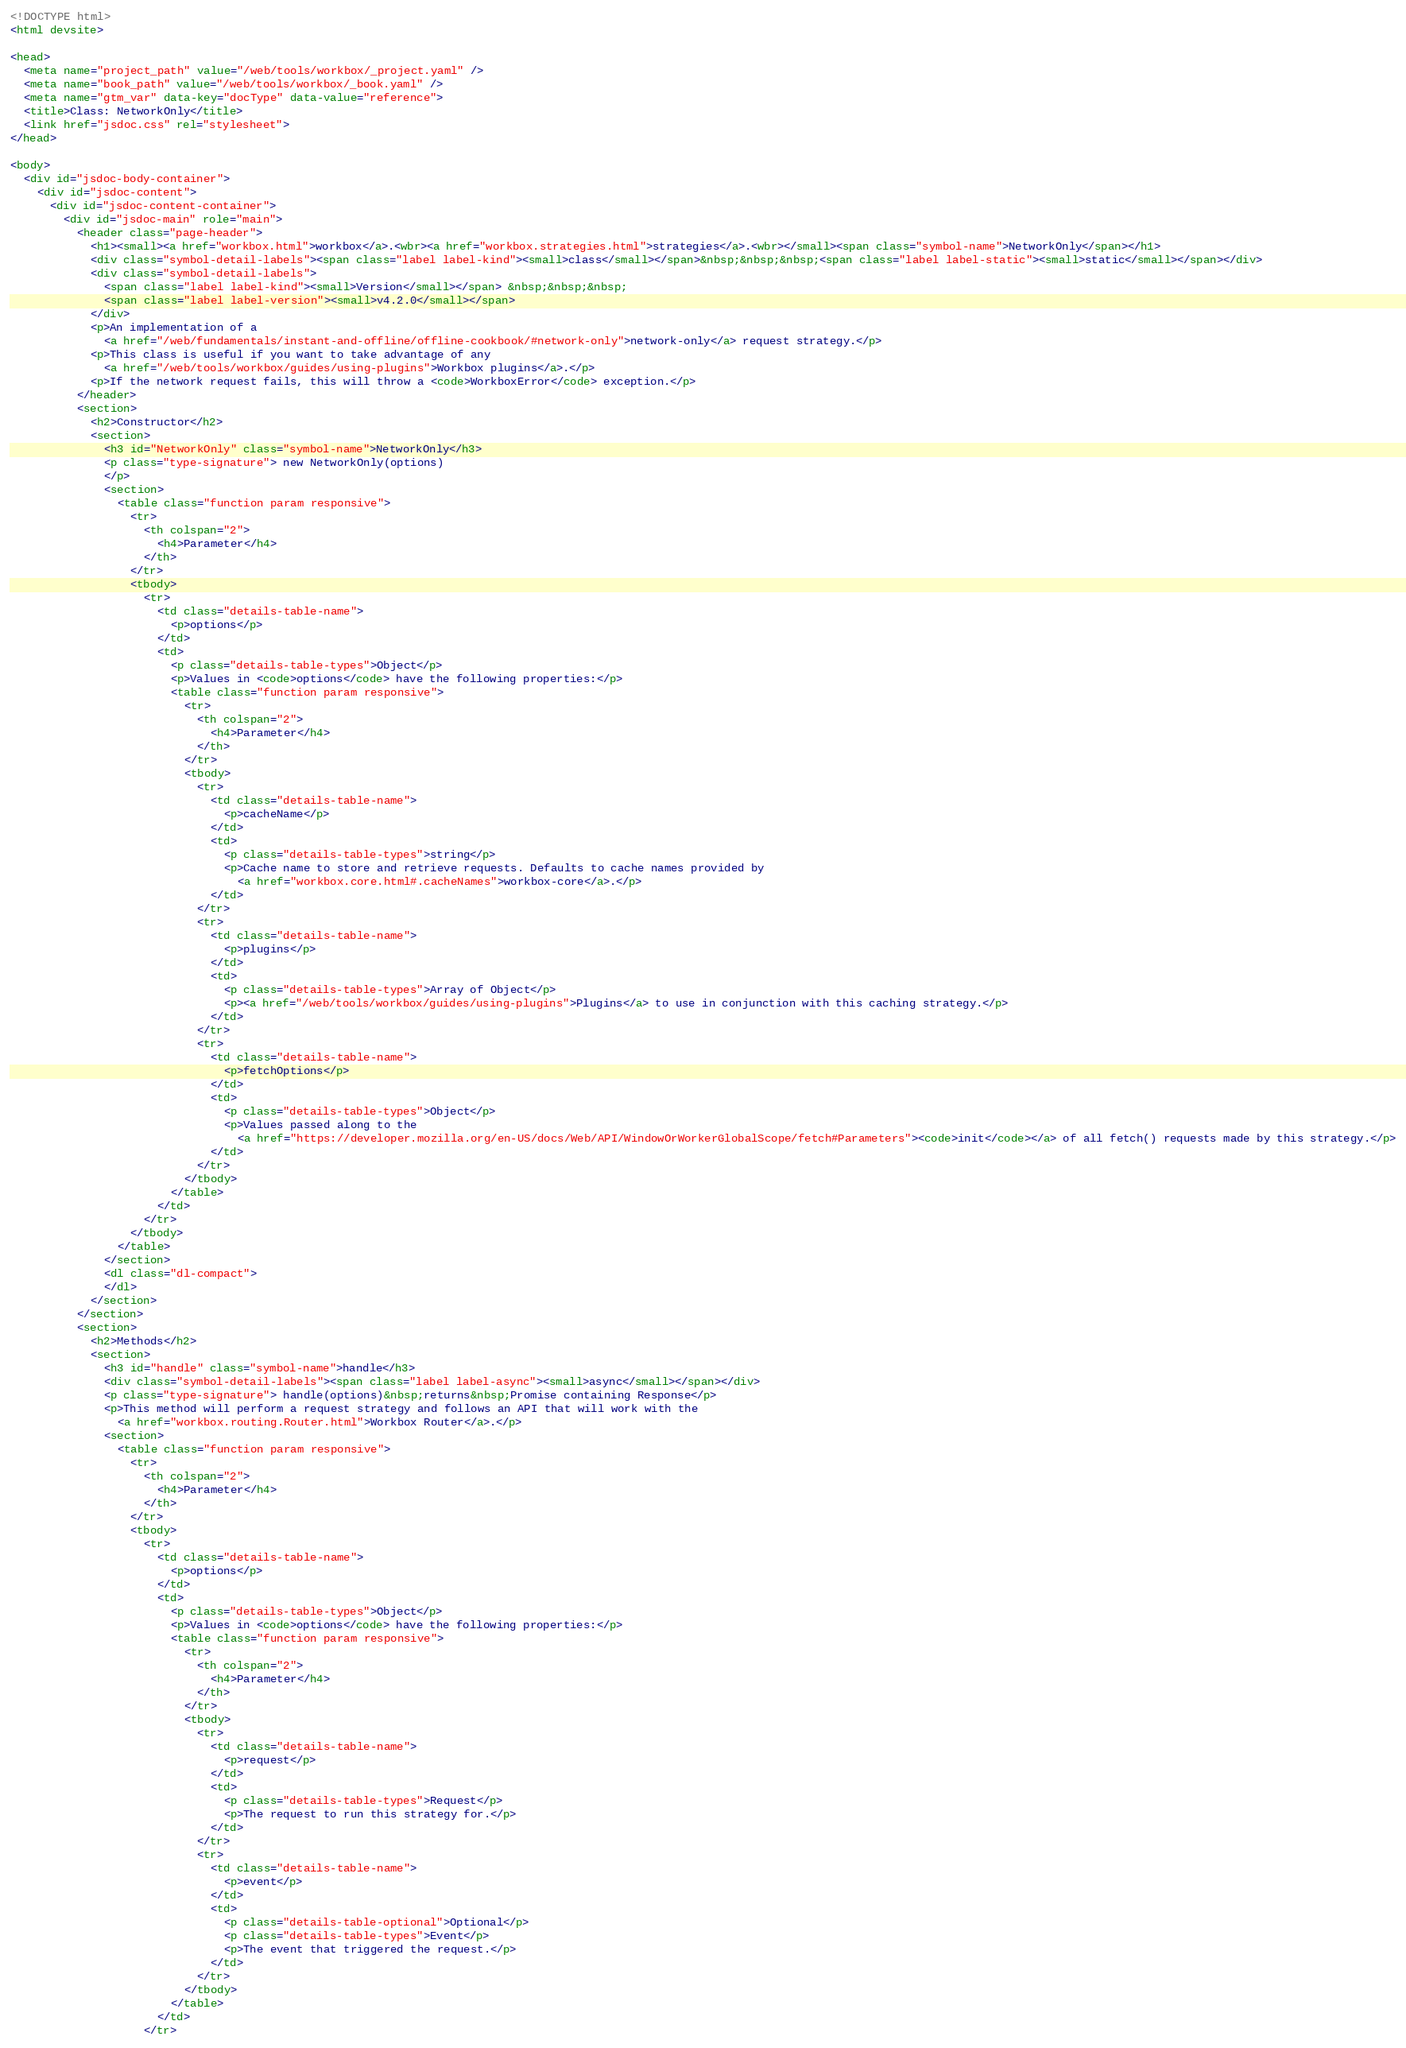Convert code to text. <code><loc_0><loc_0><loc_500><loc_500><_HTML_><!DOCTYPE html>
<html devsite>

<head>
  <meta name="project_path" value="/web/tools/workbox/_project.yaml" />
  <meta name="book_path" value="/web/tools/workbox/_book.yaml" />
  <meta name="gtm_var" data-key="docType" data-value="reference">
  <title>Class: NetworkOnly</title>
  <link href="jsdoc.css" rel="stylesheet">
</head>

<body>
  <div id="jsdoc-body-container">
    <div id="jsdoc-content">
      <div id="jsdoc-content-container">
        <div id="jsdoc-main" role="main">
          <header class="page-header">
            <h1><small><a href="workbox.html">workbox</a>.<wbr><a href="workbox.strategies.html">strategies</a>.<wbr></small><span class="symbol-name">NetworkOnly</span></h1>
            <div class="symbol-detail-labels"><span class="label label-kind"><small>class</small></span>&nbsp;&nbsp;&nbsp;<span class="label label-static"><small>static</small></span></div>
            <div class="symbol-detail-labels">
              <span class="label label-kind"><small>Version</small></span> &nbsp;&nbsp;&nbsp;
              <span class="label label-version"><small>v4.2.0</small></span>
            </div>
            <p>An implementation of a
              <a href="/web/fundamentals/instant-and-offline/offline-cookbook/#network-only">network-only</a> request strategy.</p>
            <p>This class is useful if you want to take advantage of any
              <a href="/web/tools/workbox/guides/using-plugins">Workbox plugins</a>.</p>
            <p>If the network request fails, this will throw a <code>WorkboxError</code> exception.</p>
          </header>
          <section>
            <h2>Constructor</h2>
            <section>
              <h3 id="NetworkOnly" class="symbol-name">NetworkOnly</h3>
              <p class="type-signature"> new NetworkOnly(options)
              </p>
              <section>
                <table class="function param responsive">
                  <tr>
                    <th colspan="2">
                      <h4>Parameter</h4>
                    </th>
                  </tr>
                  <tbody>
                    <tr>
                      <td class="details-table-name">
                        <p>options</p>
                      </td>
                      <td>
                        <p class="details-table-types">Object</p>
                        <p>Values in <code>options</code> have the following properties:</p>
                        <table class="function param responsive">
                          <tr>
                            <th colspan="2">
                              <h4>Parameter</h4>
                            </th>
                          </tr>
                          <tbody>
                            <tr>
                              <td class="details-table-name">
                                <p>cacheName</p>
                              </td>
                              <td>
                                <p class="details-table-types">string</p>
                                <p>Cache name to store and retrieve requests. Defaults to cache names provided by
                                  <a href="workbox.core.html#.cacheNames">workbox-core</a>.</p>
                              </td>
                            </tr>
                            <tr>
                              <td class="details-table-name">
                                <p>plugins</p>
                              </td>
                              <td>
                                <p class="details-table-types">Array of Object</p>
                                <p><a href="/web/tools/workbox/guides/using-plugins">Plugins</a> to use in conjunction with this caching strategy.</p>
                              </td>
                            </tr>
                            <tr>
                              <td class="details-table-name">
                                <p>fetchOptions</p>
                              </td>
                              <td>
                                <p class="details-table-types">Object</p>
                                <p>Values passed along to the
                                  <a href="https://developer.mozilla.org/en-US/docs/Web/API/WindowOrWorkerGlobalScope/fetch#Parameters"><code>init</code></a> of all fetch() requests made by this strategy.</p>
                              </td>
                            </tr>
                          </tbody>
                        </table>
                      </td>
                    </tr>
                  </tbody>
                </table>
              </section>
              <dl class="dl-compact">
              </dl>
            </section>
          </section>
          <section>
            <h2>Methods</h2>
            <section>
              <h3 id="handle" class="symbol-name">handle</h3>
              <div class="symbol-detail-labels"><span class="label label-async"><small>async</small></span></div>
              <p class="type-signature"> handle(options)&nbsp;returns&nbsp;Promise containing Response</p>
              <p>This method will perform a request strategy and follows an API that will work with the
                <a href="workbox.routing.Router.html">Workbox Router</a>.</p>
              <section>
                <table class="function param responsive">
                  <tr>
                    <th colspan="2">
                      <h4>Parameter</h4>
                    </th>
                  </tr>
                  <tbody>
                    <tr>
                      <td class="details-table-name">
                        <p>options</p>
                      </td>
                      <td>
                        <p class="details-table-types">Object</p>
                        <p>Values in <code>options</code> have the following properties:</p>
                        <table class="function param responsive">
                          <tr>
                            <th colspan="2">
                              <h4>Parameter</h4>
                            </th>
                          </tr>
                          <tbody>
                            <tr>
                              <td class="details-table-name">
                                <p>request</p>
                              </td>
                              <td>
                                <p class="details-table-types">Request</p>
                                <p>The request to run this strategy for.</p>
                              </td>
                            </tr>
                            <tr>
                              <td class="details-table-name">
                                <p>event</p>
                              </td>
                              <td>
                                <p class="details-table-optional">Optional</p>
                                <p class="details-table-types">Event</p>
                                <p>The event that triggered the request.</p>
                              </td>
                            </tr>
                          </tbody>
                        </table>
                      </td>
                    </tr></code> 